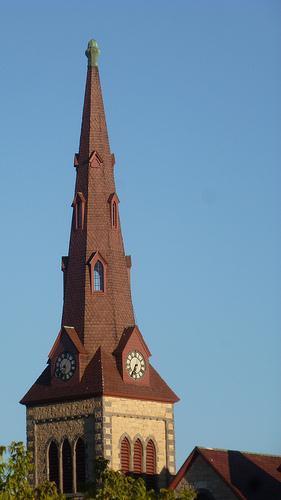How many clocks are there?
Give a very brief answer. 2. 